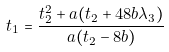Convert formula to latex. <formula><loc_0><loc_0><loc_500><loc_500>t _ { 1 } = \frac { t _ { 2 } ^ { 2 } + a ( t _ { 2 } + 4 8 b \lambda _ { 3 } ) } { a ( t _ { 2 } - 8 b ) }</formula> 